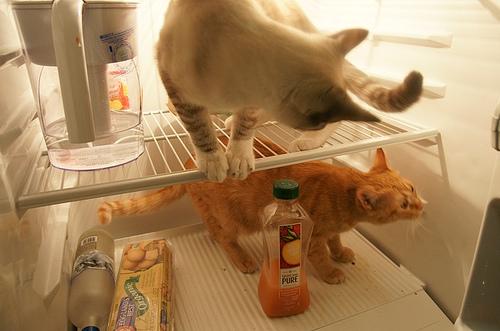Are the cats sitting inside an oven?
Concise answer only. No. Are the cats awake?
Write a very short answer. Yes. Are these cats the same breed?
Quick response, please. No. Where are the cats?
Keep it brief. In refrigerator. 